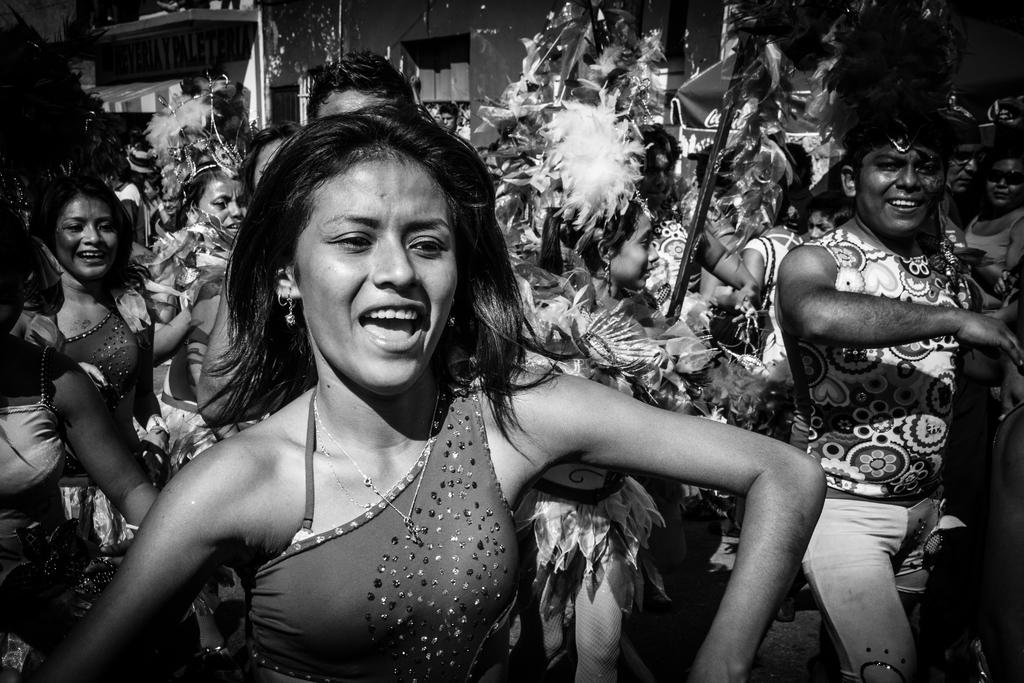How many people are in the image? There are people in the image, but the exact number is not specified. What are some of the people wearing? Some of the people are wearing costumes. What can be seen in the background of the image? There are buildings in the background of the image. What is the color scheme of the image? The image is black and white. What type of roof can be seen on the expansion in the image? There is no mention of an expansion or a roof in the image, as it only features people, costumes, and buildings in the background. 